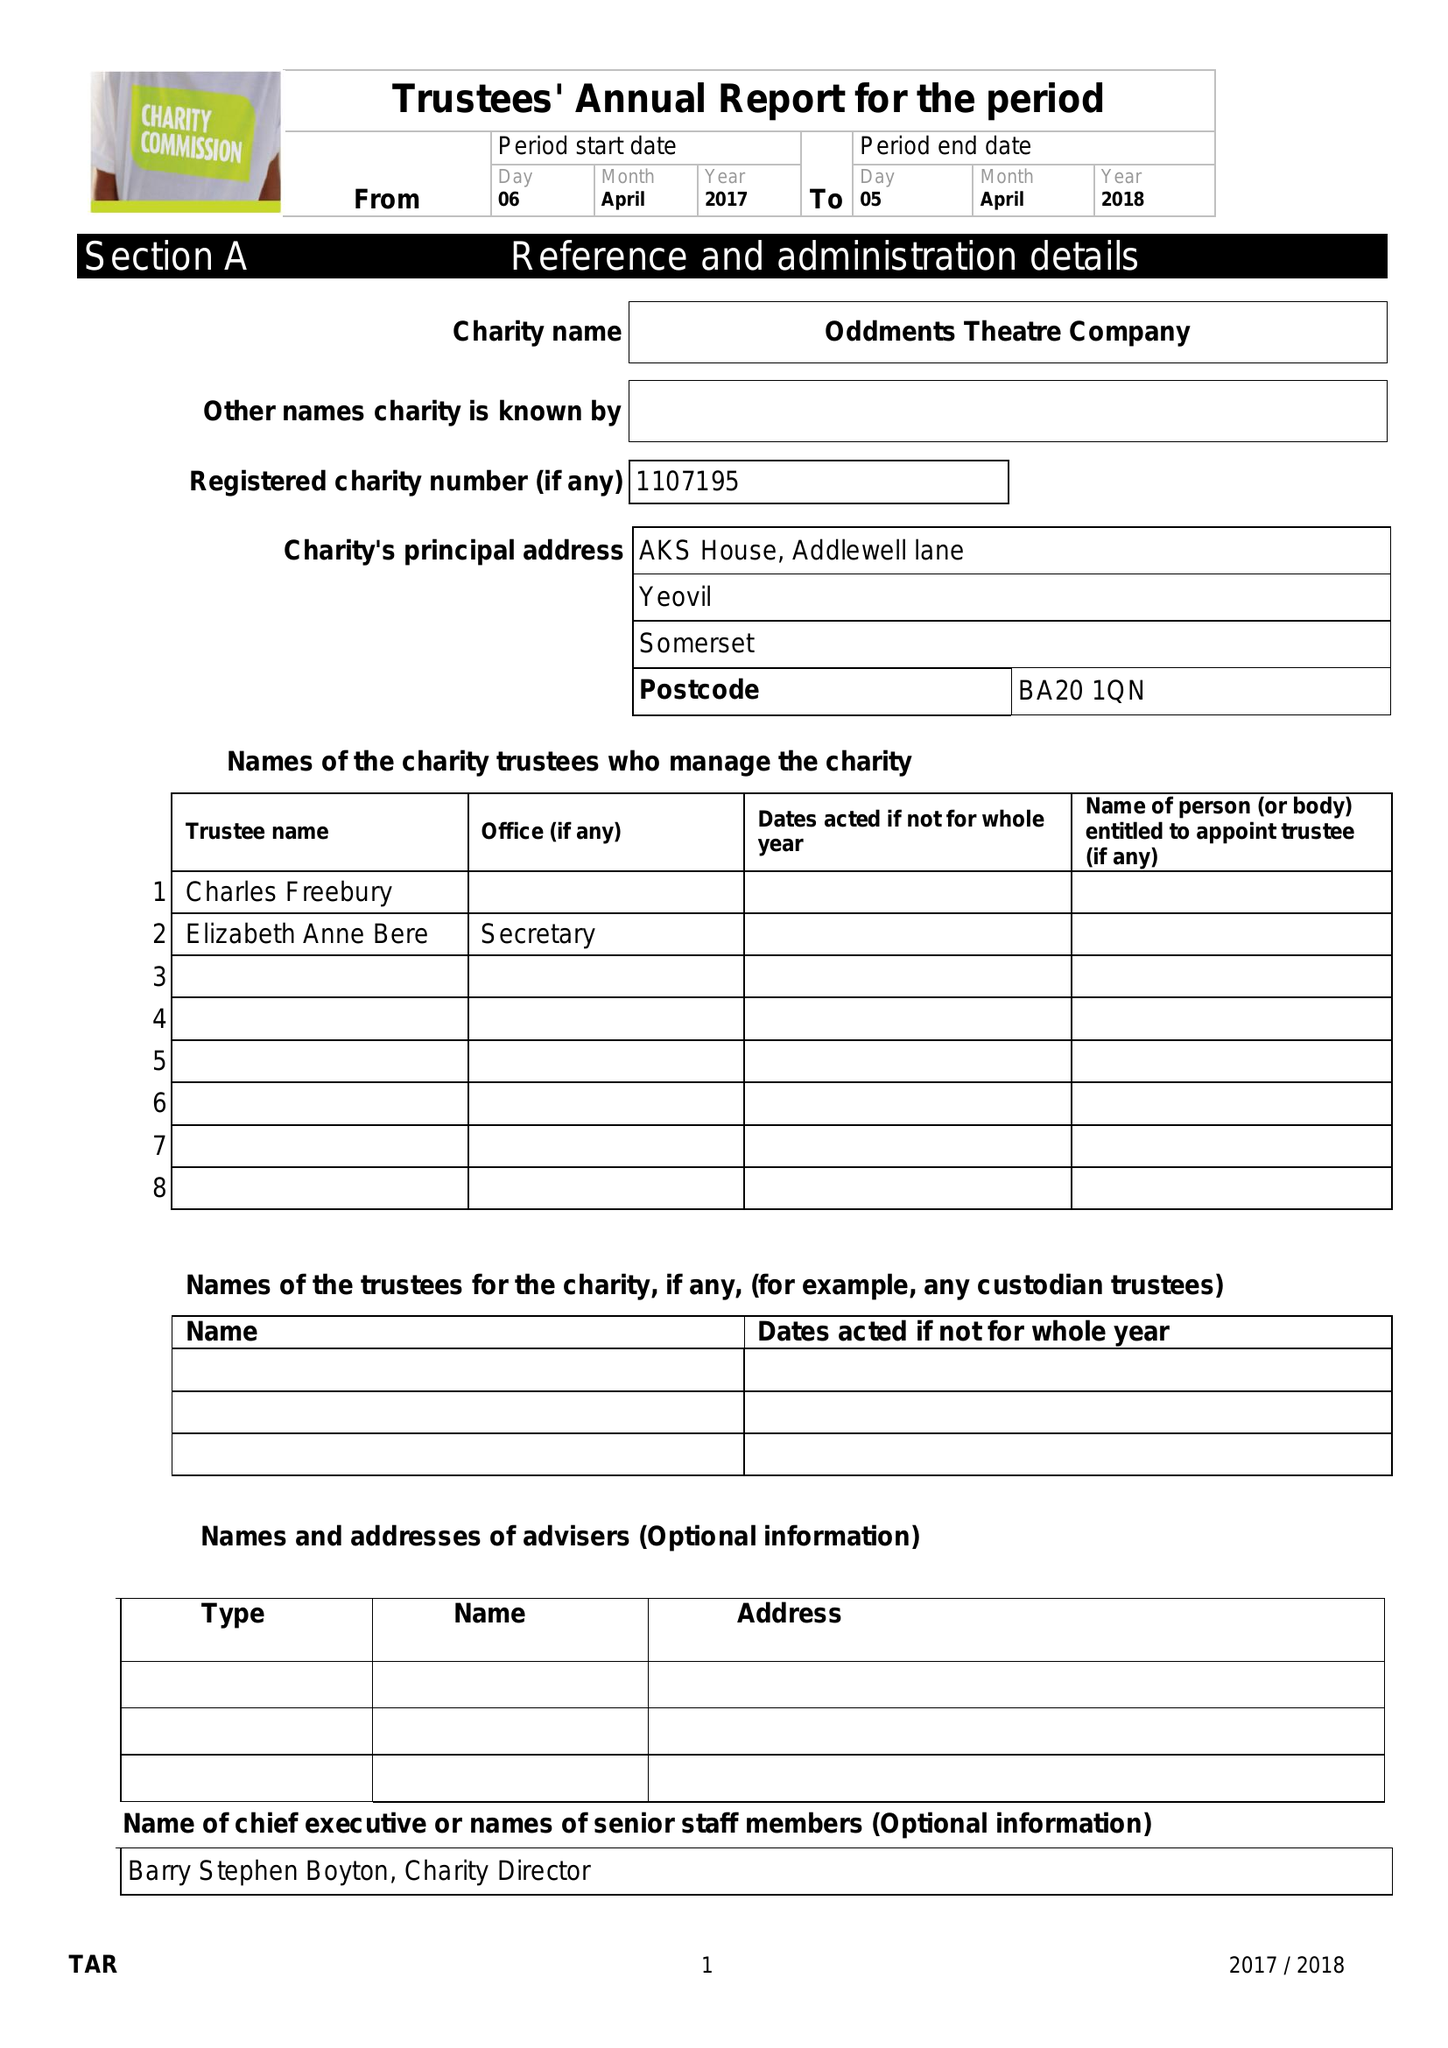What is the value for the address__postcode?
Answer the question using a single word or phrase. BA20 1QN 